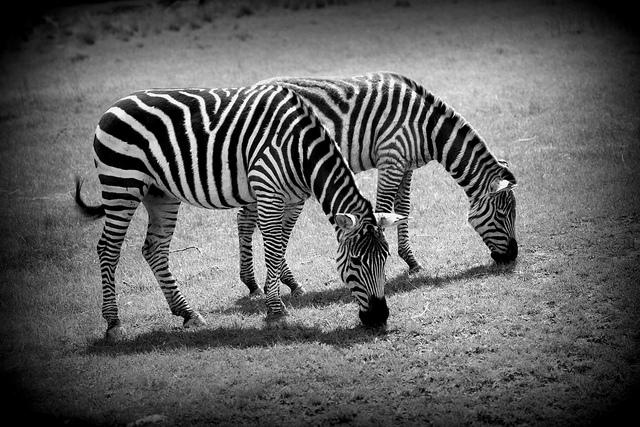How many tails are there?
Answer briefly. 1. Is the image in black and white?
Answer briefly. Yes. How many zebras are there?
Keep it brief. 2. 